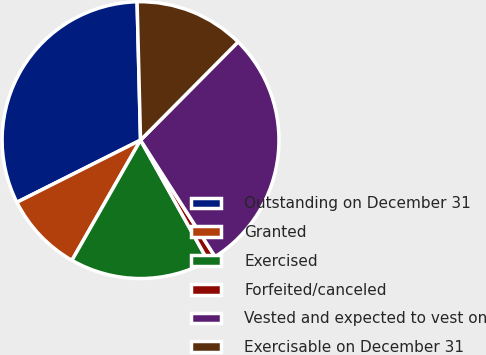Convert chart. <chart><loc_0><loc_0><loc_500><loc_500><pie_chart><fcel>Outstanding on December 31<fcel>Granted<fcel>Exercised<fcel>Forfeited/canceled<fcel>Vested and expected to vest on<fcel>Exercisable on December 31<nl><fcel>32.02%<fcel>9.33%<fcel>16.36%<fcel>0.95%<fcel>28.5%<fcel>12.84%<nl></chart> 